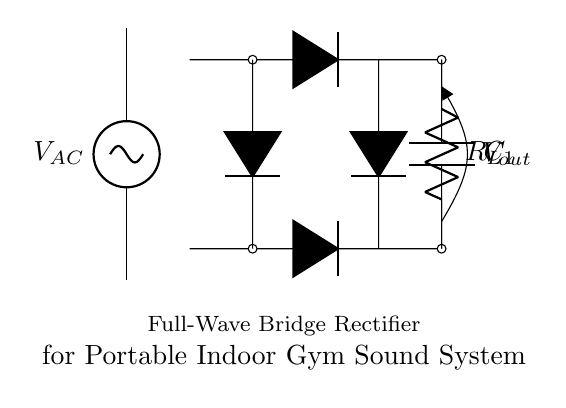What type of rectifier is used in this circuit? The circuit uses a full-wave bridge rectifier, which can be identified by the four diodes arranged in a bridge configuration that allows current to flow in both directions, converting AC to DC effectively.
Answer: Full-wave bridge rectifier What is the purpose of the capacitor in this circuit? The capacitor smooths the output voltage by storing energy and releasing it when the voltage from the rectifier drops, thus reducing ripple and providing a more constant DC output.
Answer: Smooth output voltage How many diodes are present in this circuit? There are four diodes used in the bridge rectifier configuration, which are essential for converting both halves of the AC waveform into DC, ensuring that the load receives current in one direction.
Answer: Four diodes What is the role of the load resistor labeled in the circuit? The load resistor provides the necessary load for the circuit to draw current and simulate the conditions under which the rectified voltage can be measured; it represents the actual speaker or output device used in the sound system.
Answer: Provide load for the circuit What happens to the output voltage if the capacitor is absent? If the capacitor is absent, the output voltage would fluctuate with the AC input waveform, resulting in a higher ripple voltage and a less stable DC output, which could negatively impact the performance of the sound system.
Answer: Increased ripple voltage What is the purpose of the AC source in this circuit? The AC source provides the alternating current necessary to be converted into direct current by the rectifier, enabling the power required for the portable indoor gym sound system to operate properly.
Answer: Provide input power 